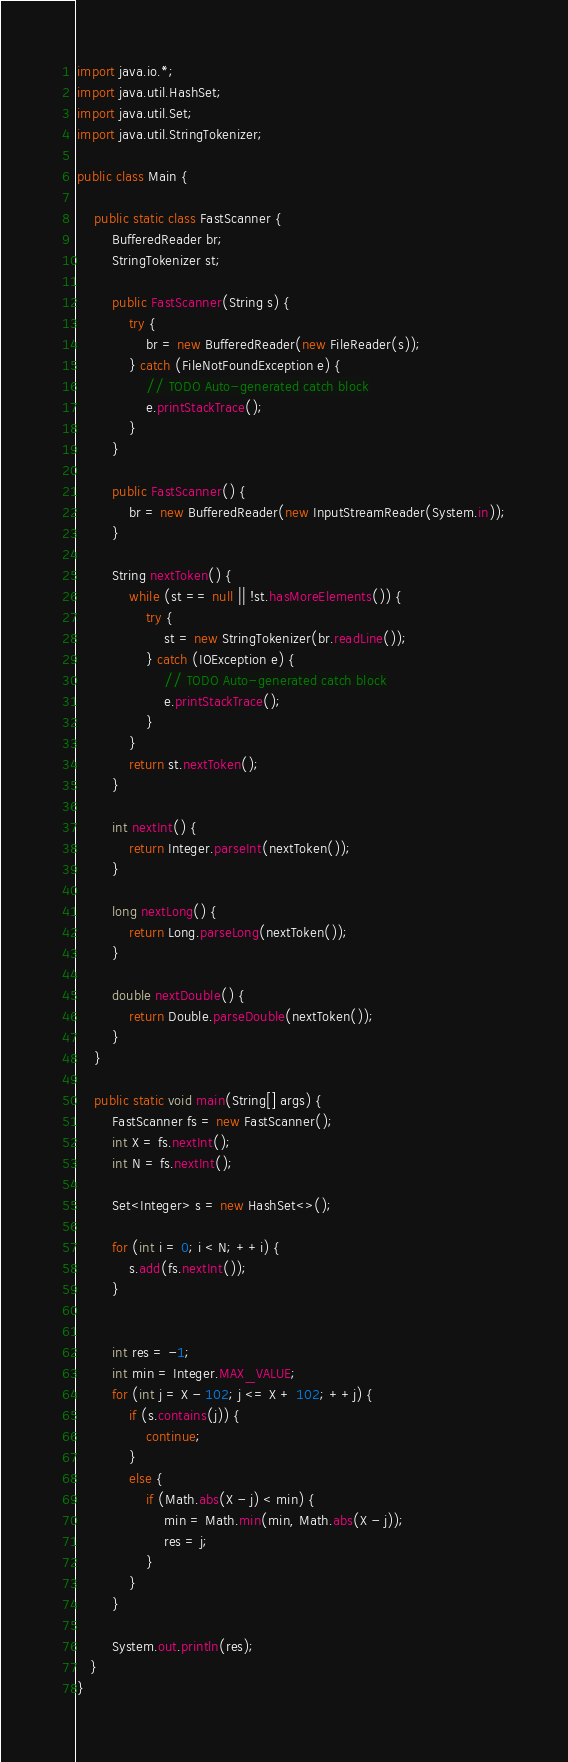Convert code to text. <code><loc_0><loc_0><loc_500><loc_500><_Java_>import java.io.*;
import java.util.HashSet;
import java.util.Set;
import java.util.StringTokenizer;

public class Main {

    public static class FastScanner {
        BufferedReader br;
        StringTokenizer st;

        public FastScanner(String s) {
            try {
                br = new BufferedReader(new FileReader(s));
            } catch (FileNotFoundException e) {
                // TODO Auto-generated catch block
                e.printStackTrace();
            }
        }

        public FastScanner() {
            br = new BufferedReader(new InputStreamReader(System.in));
        }

        String nextToken() {
            while (st == null || !st.hasMoreElements()) {
                try {
                    st = new StringTokenizer(br.readLine());
                } catch (IOException e) {
                    // TODO Auto-generated catch block
                    e.printStackTrace();
                }
            }
            return st.nextToken();
        }

        int nextInt() {
            return Integer.parseInt(nextToken());
        }

        long nextLong() {
            return Long.parseLong(nextToken());
        }

        double nextDouble() {
            return Double.parseDouble(nextToken());
        }
    }

    public static void main(String[] args) {
        FastScanner fs = new FastScanner();
        int X = fs.nextInt();
        int N = fs.nextInt();

        Set<Integer> s = new HashSet<>();

        for (int i = 0; i < N; ++i) {
            s.add(fs.nextInt());
        }


        int res = -1;
        int min = Integer.MAX_VALUE;
        for (int j = X - 102; j <= X + 102; ++j) {
            if (s.contains(j)) {
                continue;
            }
            else {
                if (Math.abs(X - j) < min) {
                    min = Math.min(min, Math.abs(X - j));
                    res = j;
                }
            }
        }

        System.out.println(res);
   }
}
</code> 